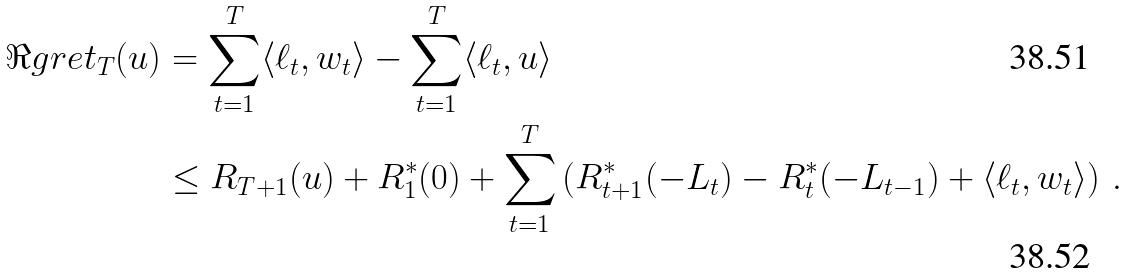<formula> <loc_0><loc_0><loc_500><loc_500>\Re g r e t _ { T } ( u ) & = \sum _ { t = 1 } ^ { T } \langle \ell _ { t } , w _ { t } \rangle - \sum _ { t = 1 } ^ { T } \langle \ell _ { t } , u \rangle \\ & \leq R _ { T + 1 } ( u ) + R _ { 1 } ^ { * } ( 0 ) + \sum _ { t = 1 } ^ { T } \left ( R _ { t + 1 } ^ { * } ( - L _ { t } ) - R _ { t } ^ { * } ( - L _ { t - 1 } ) + \langle \ell _ { t } , w _ { t } \rangle \right ) \, .</formula> 